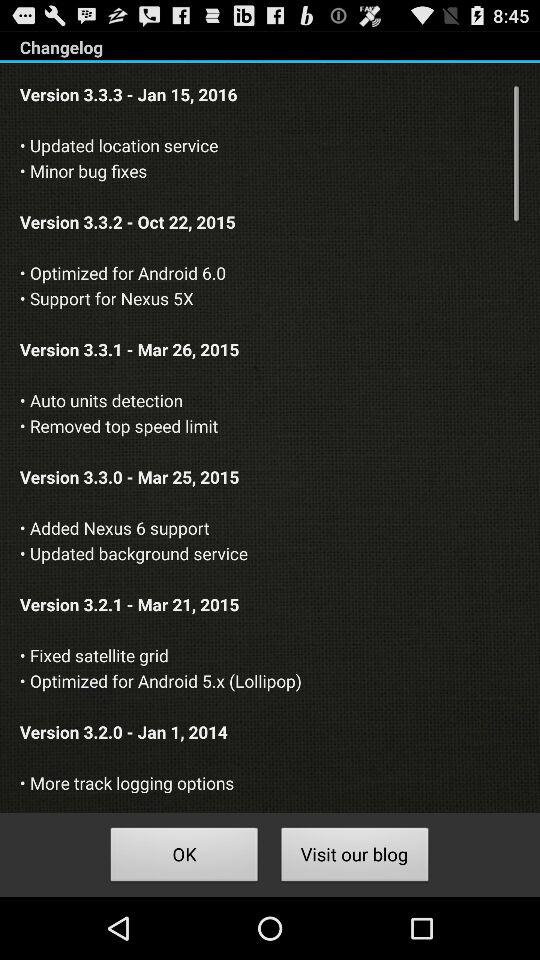Which version supports "Nexus 5X"? "Nexus 5X" is supported by version 3.3.2. 